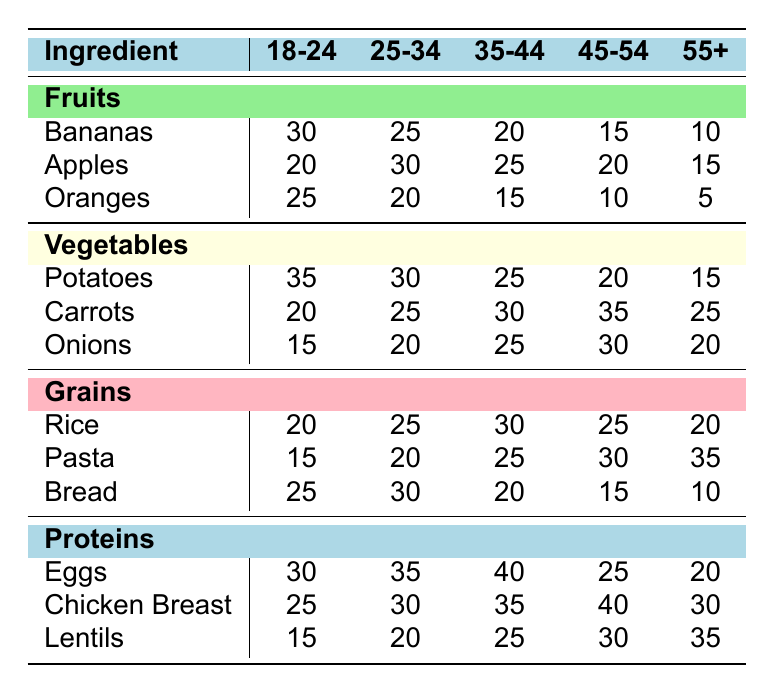What age group purchases the most bananas? The table shows that the age group 18-24 purchases the most bananas at a count of 30, which is higher than other age groups.
Answer: 18-24 Which vegetable has the highest count among the 45-54 age group? In the 45-54 age group, the highest count is for carrots, which is 35, compared to potatoes at 20 and onions at 30.
Answer: Carrots What is the total count of fruits purchased by the 25-34 age group? We sum the counts of the fruits for the 25-34 age group: Bananas (25) + Apples (30) + Oranges (20) = 75.
Answer: 75 Is it true that people aged 55+ purchase more lentils than eggs? The count for lentils in the 55+ age group is 35, while the count for eggs is 20. Therefore, this statement is true.
Answer: Yes What is the average count of grains purchased by the 35-44 age group? The grains count for the 35-44 age group is as follows: Rice (30), Pasta (25), and Bread (20). The total is 30 + 25 + 20 = 75, and the average is 75/3 = 25.
Answer: 25 Which ingredient is most favored by the 18-24 age group? By checking the maximum values in the 18-24 age group, we find that the ingredient with the highest purchase count is potatoes (35) compared to other ingredients in that age group.
Answer: Potatoes How does the purchase of chicken breast by the 45-54 age group compare to that of the 18-24 age group? For the 45-54 age group, the count for chicken breast is 40, while for the 18-24 age group, it is 25. Thus, the 45-54 age group purchases 15 more chicken breasts than the 18-24 age group.
Answer: 15 more Which age group has the least purchase of oranges? The table shows that the 55+ age group has the least purchase of oranges, with a count of 5, which is lower than the other age groups.
Answer: 55+ 